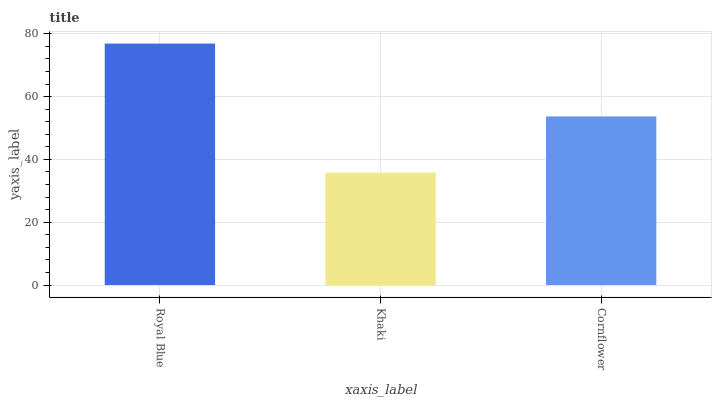Is Khaki the minimum?
Answer yes or no. Yes. Is Royal Blue the maximum?
Answer yes or no. Yes. Is Cornflower the minimum?
Answer yes or no. No. Is Cornflower the maximum?
Answer yes or no. No. Is Cornflower greater than Khaki?
Answer yes or no. Yes. Is Khaki less than Cornflower?
Answer yes or no. Yes. Is Khaki greater than Cornflower?
Answer yes or no. No. Is Cornflower less than Khaki?
Answer yes or no. No. Is Cornflower the high median?
Answer yes or no. Yes. Is Cornflower the low median?
Answer yes or no. Yes. Is Khaki the high median?
Answer yes or no. No. Is Royal Blue the low median?
Answer yes or no. No. 